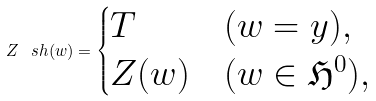<formula> <loc_0><loc_0><loc_500><loc_500>Z ^ { \ } s h ( w ) = \begin{cases} T & ( w = y ) , \\ Z ( w ) & ( w \in \mathfrak { H } ^ { 0 } ) , \end{cases}</formula> 